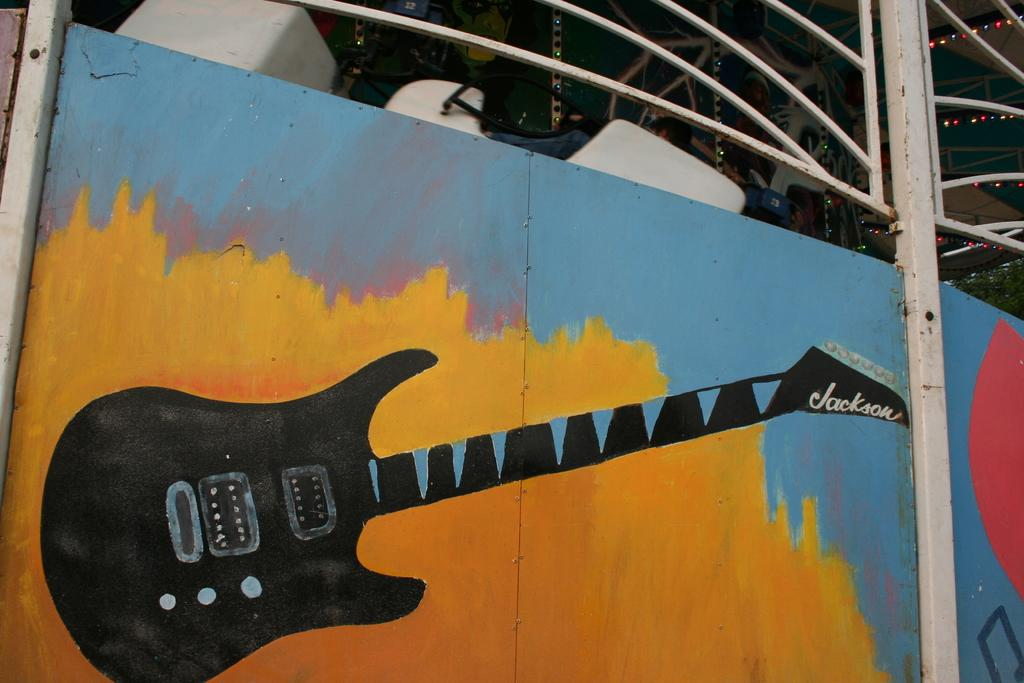What is the main object in the image? There is a gate in the image. Is there anything unique about the gate? Yes, there is a painting on the gate. What is depicted in the painting? The painting features a guitar. How many matches are being used to light the guitar in the painting? There are no matches present in the image, as the painting features a guitar without any indication of being lit. 